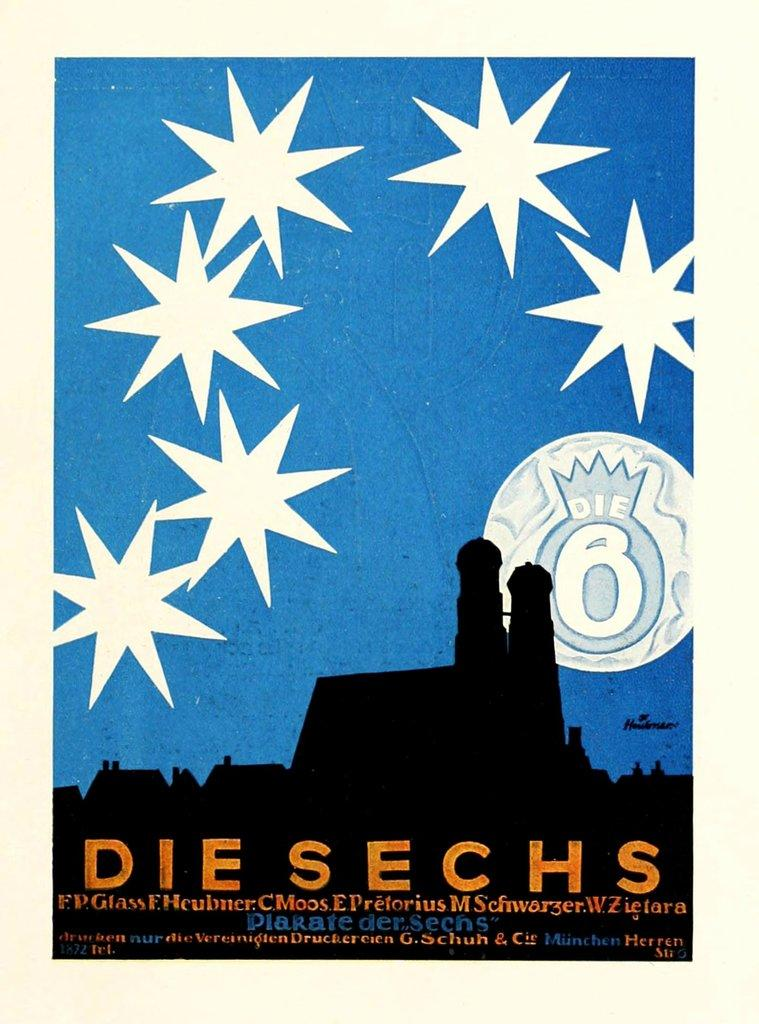<image>
Relay a brief, clear account of the picture shown. A poster of a moon and stars titled "Die Sechs." 